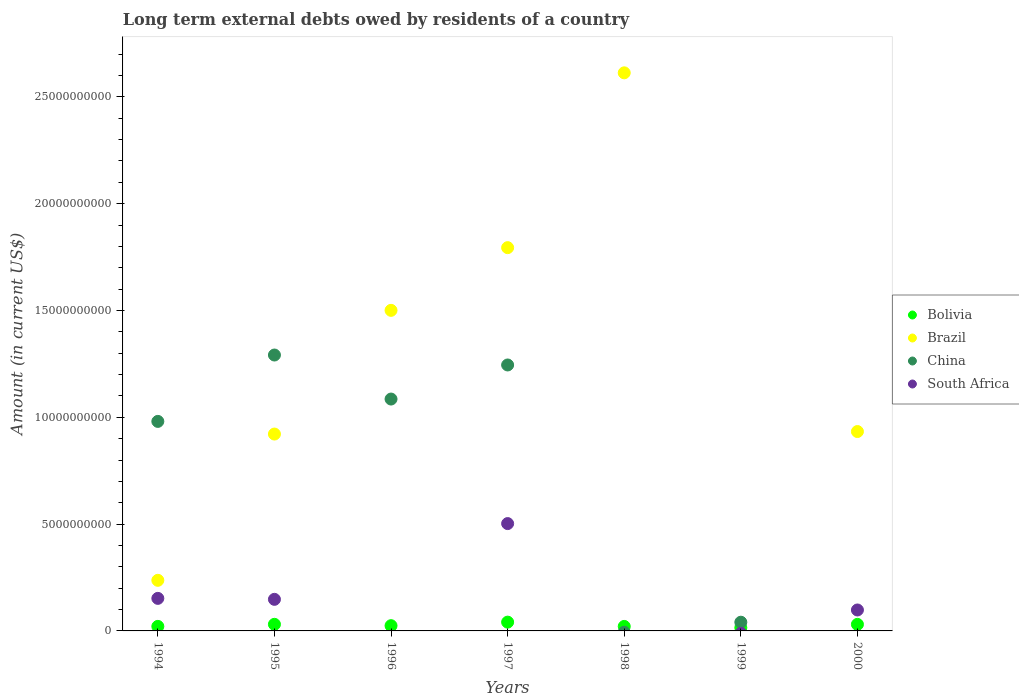How many different coloured dotlines are there?
Keep it short and to the point. 4. What is the amount of long-term external debts owed by residents in Brazil in 1999?
Provide a short and direct response. 0. Across all years, what is the maximum amount of long-term external debts owed by residents in South Africa?
Keep it short and to the point. 5.02e+09. What is the total amount of long-term external debts owed by residents in China in the graph?
Ensure brevity in your answer.  4.64e+1. What is the difference between the amount of long-term external debts owed by residents in South Africa in 1994 and that in 1995?
Offer a terse response. 4.52e+07. What is the difference between the amount of long-term external debts owed by residents in Brazil in 1995 and the amount of long-term external debts owed by residents in South Africa in 1997?
Ensure brevity in your answer.  4.19e+09. What is the average amount of long-term external debts owed by residents in China per year?
Make the answer very short. 6.63e+09. In the year 1997, what is the difference between the amount of long-term external debts owed by residents in Brazil and amount of long-term external debts owed by residents in South Africa?
Offer a terse response. 1.29e+1. In how many years, is the amount of long-term external debts owed by residents in Brazil greater than 8000000000 US$?
Offer a very short reply. 5. What is the ratio of the amount of long-term external debts owed by residents in South Africa in 1994 to that in 1997?
Provide a succinct answer. 0.3. What is the difference between the highest and the second highest amount of long-term external debts owed by residents in Brazil?
Provide a short and direct response. 8.18e+09. What is the difference between the highest and the lowest amount of long-term external debts owed by residents in Bolivia?
Offer a terse response. 2.60e+08. In how many years, is the amount of long-term external debts owed by residents in Brazil greater than the average amount of long-term external debts owed by residents in Brazil taken over all years?
Keep it short and to the point. 3. Is the sum of the amount of long-term external debts owed by residents in Bolivia in 1997 and 1999 greater than the maximum amount of long-term external debts owed by residents in South Africa across all years?
Provide a succinct answer. No. Is it the case that in every year, the sum of the amount of long-term external debts owed by residents in China and amount of long-term external debts owed by residents in South Africa  is greater than the sum of amount of long-term external debts owed by residents in Bolivia and amount of long-term external debts owed by residents in Brazil?
Provide a short and direct response. No. Does the amount of long-term external debts owed by residents in Bolivia monotonically increase over the years?
Your answer should be very brief. No. How many dotlines are there?
Your response must be concise. 4. How many years are there in the graph?
Offer a terse response. 7. What is the difference between two consecutive major ticks on the Y-axis?
Offer a very short reply. 5.00e+09. Are the values on the major ticks of Y-axis written in scientific E-notation?
Ensure brevity in your answer.  No. Does the graph contain any zero values?
Your answer should be very brief. Yes. How are the legend labels stacked?
Provide a short and direct response. Vertical. What is the title of the graph?
Your response must be concise. Long term external debts owed by residents of a country. Does "Iceland" appear as one of the legend labels in the graph?
Give a very brief answer. No. What is the label or title of the X-axis?
Offer a terse response. Years. What is the Amount (in current US$) in Bolivia in 1994?
Your response must be concise. 2.12e+08. What is the Amount (in current US$) of Brazil in 1994?
Ensure brevity in your answer.  2.37e+09. What is the Amount (in current US$) of China in 1994?
Offer a terse response. 9.81e+09. What is the Amount (in current US$) of South Africa in 1994?
Offer a terse response. 1.52e+09. What is the Amount (in current US$) in Bolivia in 1995?
Make the answer very short. 3.09e+08. What is the Amount (in current US$) of Brazil in 1995?
Keep it short and to the point. 9.22e+09. What is the Amount (in current US$) in China in 1995?
Give a very brief answer. 1.29e+1. What is the Amount (in current US$) of South Africa in 1995?
Provide a succinct answer. 1.48e+09. What is the Amount (in current US$) of Bolivia in 1996?
Keep it short and to the point. 2.46e+08. What is the Amount (in current US$) in Brazil in 1996?
Give a very brief answer. 1.50e+1. What is the Amount (in current US$) of China in 1996?
Your answer should be very brief. 1.09e+1. What is the Amount (in current US$) of South Africa in 1996?
Offer a very short reply. 0. What is the Amount (in current US$) of Bolivia in 1997?
Provide a short and direct response. 4.11e+08. What is the Amount (in current US$) of Brazil in 1997?
Ensure brevity in your answer.  1.79e+1. What is the Amount (in current US$) of China in 1997?
Provide a short and direct response. 1.24e+1. What is the Amount (in current US$) of South Africa in 1997?
Offer a very short reply. 5.02e+09. What is the Amount (in current US$) in Bolivia in 1998?
Offer a terse response. 2.10e+08. What is the Amount (in current US$) of Brazil in 1998?
Provide a short and direct response. 2.61e+1. What is the Amount (in current US$) of China in 1998?
Give a very brief answer. 0. What is the Amount (in current US$) in South Africa in 1998?
Your response must be concise. 0. What is the Amount (in current US$) of Bolivia in 1999?
Make the answer very short. 1.51e+08. What is the Amount (in current US$) of China in 1999?
Give a very brief answer. 4.08e+08. What is the Amount (in current US$) of Bolivia in 2000?
Offer a very short reply. 3.07e+08. What is the Amount (in current US$) in Brazil in 2000?
Your answer should be compact. 9.33e+09. What is the Amount (in current US$) of South Africa in 2000?
Keep it short and to the point. 9.80e+08. Across all years, what is the maximum Amount (in current US$) of Bolivia?
Your answer should be very brief. 4.11e+08. Across all years, what is the maximum Amount (in current US$) in Brazil?
Give a very brief answer. 2.61e+1. Across all years, what is the maximum Amount (in current US$) of China?
Offer a terse response. 1.29e+1. Across all years, what is the maximum Amount (in current US$) in South Africa?
Provide a short and direct response. 5.02e+09. Across all years, what is the minimum Amount (in current US$) of Bolivia?
Ensure brevity in your answer.  1.51e+08. Across all years, what is the minimum Amount (in current US$) of South Africa?
Provide a succinct answer. 0. What is the total Amount (in current US$) in Bolivia in the graph?
Offer a very short reply. 1.85e+09. What is the total Amount (in current US$) of Brazil in the graph?
Ensure brevity in your answer.  8.00e+1. What is the total Amount (in current US$) of China in the graph?
Your answer should be compact. 4.64e+1. What is the total Amount (in current US$) in South Africa in the graph?
Your response must be concise. 9.01e+09. What is the difference between the Amount (in current US$) of Bolivia in 1994 and that in 1995?
Your response must be concise. -9.73e+07. What is the difference between the Amount (in current US$) in Brazil in 1994 and that in 1995?
Keep it short and to the point. -6.85e+09. What is the difference between the Amount (in current US$) in China in 1994 and that in 1995?
Keep it short and to the point. -3.11e+09. What is the difference between the Amount (in current US$) in South Africa in 1994 and that in 1995?
Provide a short and direct response. 4.52e+07. What is the difference between the Amount (in current US$) in Bolivia in 1994 and that in 1996?
Give a very brief answer. -3.39e+07. What is the difference between the Amount (in current US$) in Brazil in 1994 and that in 1996?
Keep it short and to the point. -1.26e+1. What is the difference between the Amount (in current US$) in China in 1994 and that in 1996?
Your answer should be very brief. -1.05e+09. What is the difference between the Amount (in current US$) of Bolivia in 1994 and that in 1997?
Your answer should be very brief. -1.99e+08. What is the difference between the Amount (in current US$) of Brazil in 1994 and that in 1997?
Your answer should be compact. -1.56e+1. What is the difference between the Amount (in current US$) of China in 1994 and that in 1997?
Your answer should be compact. -2.64e+09. What is the difference between the Amount (in current US$) in South Africa in 1994 and that in 1997?
Provide a short and direct response. -3.50e+09. What is the difference between the Amount (in current US$) of Bolivia in 1994 and that in 1998?
Keep it short and to the point. 1.55e+06. What is the difference between the Amount (in current US$) in Brazil in 1994 and that in 1998?
Provide a short and direct response. -2.38e+1. What is the difference between the Amount (in current US$) in Bolivia in 1994 and that in 1999?
Your answer should be very brief. 6.07e+07. What is the difference between the Amount (in current US$) of China in 1994 and that in 1999?
Provide a short and direct response. 9.40e+09. What is the difference between the Amount (in current US$) in Bolivia in 1994 and that in 2000?
Your answer should be compact. -9.52e+07. What is the difference between the Amount (in current US$) in Brazil in 1994 and that in 2000?
Ensure brevity in your answer.  -6.96e+09. What is the difference between the Amount (in current US$) of South Africa in 1994 and that in 2000?
Offer a terse response. 5.43e+08. What is the difference between the Amount (in current US$) of Bolivia in 1995 and that in 1996?
Keep it short and to the point. 6.34e+07. What is the difference between the Amount (in current US$) of Brazil in 1995 and that in 1996?
Ensure brevity in your answer.  -5.79e+09. What is the difference between the Amount (in current US$) of China in 1995 and that in 1996?
Provide a short and direct response. 2.06e+09. What is the difference between the Amount (in current US$) of Bolivia in 1995 and that in 1997?
Provide a short and direct response. -1.02e+08. What is the difference between the Amount (in current US$) of Brazil in 1995 and that in 1997?
Give a very brief answer. -8.73e+09. What is the difference between the Amount (in current US$) in China in 1995 and that in 1997?
Provide a succinct answer. 4.66e+08. What is the difference between the Amount (in current US$) of South Africa in 1995 and that in 1997?
Ensure brevity in your answer.  -3.55e+09. What is the difference between the Amount (in current US$) in Bolivia in 1995 and that in 1998?
Give a very brief answer. 9.88e+07. What is the difference between the Amount (in current US$) of Brazil in 1995 and that in 1998?
Your response must be concise. -1.69e+1. What is the difference between the Amount (in current US$) in Bolivia in 1995 and that in 1999?
Your response must be concise. 1.58e+08. What is the difference between the Amount (in current US$) in China in 1995 and that in 1999?
Offer a very short reply. 1.25e+1. What is the difference between the Amount (in current US$) in Bolivia in 1995 and that in 2000?
Provide a succinct answer. 2.06e+06. What is the difference between the Amount (in current US$) in Brazil in 1995 and that in 2000?
Ensure brevity in your answer.  -1.18e+08. What is the difference between the Amount (in current US$) in South Africa in 1995 and that in 2000?
Provide a succinct answer. 4.98e+08. What is the difference between the Amount (in current US$) in Bolivia in 1996 and that in 1997?
Offer a very short reply. -1.65e+08. What is the difference between the Amount (in current US$) in Brazil in 1996 and that in 1997?
Ensure brevity in your answer.  -2.93e+09. What is the difference between the Amount (in current US$) of China in 1996 and that in 1997?
Provide a short and direct response. -1.60e+09. What is the difference between the Amount (in current US$) of Bolivia in 1996 and that in 1998?
Ensure brevity in your answer.  3.54e+07. What is the difference between the Amount (in current US$) in Brazil in 1996 and that in 1998?
Ensure brevity in your answer.  -1.11e+1. What is the difference between the Amount (in current US$) in Bolivia in 1996 and that in 1999?
Your answer should be very brief. 9.46e+07. What is the difference between the Amount (in current US$) of China in 1996 and that in 1999?
Your response must be concise. 1.04e+1. What is the difference between the Amount (in current US$) of Bolivia in 1996 and that in 2000?
Make the answer very short. -6.13e+07. What is the difference between the Amount (in current US$) in Brazil in 1996 and that in 2000?
Ensure brevity in your answer.  5.67e+09. What is the difference between the Amount (in current US$) of Bolivia in 1997 and that in 1998?
Offer a very short reply. 2.01e+08. What is the difference between the Amount (in current US$) in Brazil in 1997 and that in 1998?
Your answer should be compact. -8.18e+09. What is the difference between the Amount (in current US$) in Bolivia in 1997 and that in 1999?
Keep it short and to the point. 2.60e+08. What is the difference between the Amount (in current US$) in China in 1997 and that in 1999?
Your answer should be compact. 1.20e+1. What is the difference between the Amount (in current US$) of Bolivia in 1997 and that in 2000?
Give a very brief answer. 1.04e+08. What is the difference between the Amount (in current US$) of Brazil in 1997 and that in 2000?
Provide a succinct answer. 8.61e+09. What is the difference between the Amount (in current US$) of South Africa in 1997 and that in 2000?
Your answer should be very brief. 4.04e+09. What is the difference between the Amount (in current US$) in Bolivia in 1998 and that in 1999?
Keep it short and to the point. 5.91e+07. What is the difference between the Amount (in current US$) in Bolivia in 1998 and that in 2000?
Keep it short and to the point. -9.68e+07. What is the difference between the Amount (in current US$) in Brazil in 1998 and that in 2000?
Make the answer very short. 1.68e+1. What is the difference between the Amount (in current US$) in Bolivia in 1999 and that in 2000?
Offer a very short reply. -1.56e+08. What is the difference between the Amount (in current US$) in Bolivia in 1994 and the Amount (in current US$) in Brazil in 1995?
Your answer should be very brief. -9.00e+09. What is the difference between the Amount (in current US$) in Bolivia in 1994 and the Amount (in current US$) in China in 1995?
Keep it short and to the point. -1.27e+1. What is the difference between the Amount (in current US$) in Bolivia in 1994 and the Amount (in current US$) in South Africa in 1995?
Make the answer very short. -1.27e+09. What is the difference between the Amount (in current US$) of Brazil in 1994 and the Amount (in current US$) of China in 1995?
Your answer should be very brief. -1.05e+1. What is the difference between the Amount (in current US$) in Brazil in 1994 and the Amount (in current US$) in South Africa in 1995?
Provide a succinct answer. 8.90e+08. What is the difference between the Amount (in current US$) of China in 1994 and the Amount (in current US$) of South Africa in 1995?
Offer a terse response. 8.33e+09. What is the difference between the Amount (in current US$) in Bolivia in 1994 and the Amount (in current US$) in Brazil in 1996?
Your response must be concise. -1.48e+1. What is the difference between the Amount (in current US$) of Bolivia in 1994 and the Amount (in current US$) of China in 1996?
Offer a very short reply. -1.06e+1. What is the difference between the Amount (in current US$) in Brazil in 1994 and the Amount (in current US$) in China in 1996?
Ensure brevity in your answer.  -8.49e+09. What is the difference between the Amount (in current US$) in Bolivia in 1994 and the Amount (in current US$) in Brazil in 1997?
Ensure brevity in your answer.  -1.77e+1. What is the difference between the Amount (in current US$) in Bolivia in 1994 and the Amount (in current US$) in China in 1997?
Provide a succinct answer. -1.22e+1. What is the difference between the Amount (in current US$) in Bolivia in 1994 and the Amount (in current US$) in South Africa in 1997?
Keep it short and to the point. -4.81e+09. What is the difference between the Amount (in current US$) of Brazil in 1994 and the Amount (in current US$) of China in 1997?
Ensure brevity in your answer.  -1.01e+1. What is the difference between the Amount (in current US$) in Brazil in 1994 and the Amount (in current US$) in South Africa in 1997?
Offer a terse response. -2.66e+09. What is the difference between the Amount (in current US$) in China in 1994 and the Amount (in current US$) in South Africa in 1997?
Your answer should be very brief. 4.78e+09. What is the difference between the Amount (in current US$) of Bolivia in 1994 and the Amount (in current US$) of Brazil in 1998?
Your response must be concise. -2.59e+1. What is the difference between the Amount (in current US$) of Bolivia in 1994 and the Amount (in current US$) of China in 1999?
Provide a short and direct response. -1.96e+08. What is the difference between the Amount (in current US$) of Brazil in 1994 and the Amount (in current US$) of China in 1999?
Provide a short and direct response. 1.96e+09. What is the difference between the Amount (in current US$) of Bolivia in 1994 and the Amount (in current US$) of Brazil in 2000?
Give a very brief answer. -9.12e+09. What is the difference between the Amount (in current US$) of Bolivia in 1994 and the Amount (in current US$) of South Africa in 2000?
Offer a terse response. -7.68e+08. What is the difference between the Amount (in current US$) in Brazil in 1994 and the Amount (in current US$) in South Africa in 2000?
Give a very brief answer. 1.39e+09. What is the difference between the Amount (in current US$) in China in 1994 and the Amount (in current US$) in South Africa in 2000?
Provide a succinct answer. 8.83e+09. What is the difference between the Amount (in current US$) in Bolivia in 1995 and the Amount (in current US$) in Brazil in 1996?
Ensure brevity in your answer.  -1.47e+1. What is the difference between the Amount (in current US$) of Bolivia in 1995 and the Amount (in current US$) of China in 1996?
Provide a short and direct response. -1.05e+1. What is the difference between the Amount (in current US$) of Brazil in 1995 and the Amount (in current US$) of China in 1996?
Your answer should be compact. -1.64e+09. What is the difference between the Amount (in current US$) in Bolivia in 1995 and the Amount (in current US$) in Brazil in 1997?
Provide a succinct answer. -1.76e+1. What is the difference between the Amount (in current US$) in Bolivia in 1995 and the Amount (in current US$) in China in 1997?
Your answer should be compact. -1.21e+1. What is the difference between the Amount (in current US$) of Bolivia in 1995 and the Amount (in current US$) of South Africa in 1997?
Provide a short and direct response. -4.72e+09. What is the difference between the Amount (in current US$) of Brazil in 1995 and the Amount (in current US$) of China in 1997?
Offer a very short reply. -3.23e+09. What is the difference between the Amount (in current US$) in Brazil in 1995 and the Amount (in current US$) in South Africa in 1997?
Keep it short and to the point. 4.19e+09. What is the difference between the Amount (in current US$) of China in 1995 and the Amount (in current US$) of South Africa in 1997?
Give a very brief answer. 7.89e+09. What is the difference between the Amount (in current US$) of Bolivia in 1995 and the Amount (in current US$) of Brazil in 1998?
Ensure brevity in your answer.  -2.58e+1. What is the difference between the Amount (in current US$) of Bolivia in 1995 and the Amount (in current US$) of China in 1999?
Your response must be concise. -9.88e+07. What is the difference between the Amount (in current US$) in Brazil in 1995 and the Amount (in current US$) in China in 1999?
Provide a short and direct response. 8.81e+09. What is the difference between the Amount (in current US$) of Bolivia in 1995 and the Amount (in current US$) of Brazil in 2000?
Your answer should be very brief. -9.02e+09. What is the difference between the Amount (in current US$) in Bolivia in 1995 and the Amount (in current US$) in South Africa in 2000?
Provide a short and direct response. -6.71e+08. What is the difference between the Amount (in current US$) in Brazil in 1995 and the Amount (in current US$) in South Africa in 2000?
Provide a succinct answer. 8.23e+09. What is the difference between the Amount (in current US$) of China in 1995 and the Amount (in current US$) of South Africa in 2000?
Your answer should be very brief. 1.19e+1. What is the difference between the Amount (in current US$) of Bolivia in 1996 and the Amount (in current US$) of Brazil in 1997?
Provide a succinct answer. -1.77e+1. What is the difference between the Amount (in current US$) in Bolivia in 1996 and the Amount (in current US$) in China in 1997?
Ensure brevity in your answer.  -1.22e+1. What is the difference between the Amount (in current US$) of Bolivia in 1996 and the Amount (in current US$) of South Africa in 1997?
Give a very brief answer. -4.78e+09. What is the difference between the Amount (in current US$) of Brazil in 1996 and the Amount (in current US$) of China in 1997?
Ensure brevity in your answer.  2.56e+09. What is the difference between the Amount (in current US$) in Brazil in 1996 and the Amount (in current US$) in South Africa in 1997?
Keep it short and to the point. 9.98e+09. What is the difference between the Amount (in current US$) of China in 1996 and the Amount (in current US$) of South Africa in 1997?
Provide a succinct answer. 5.83e+09. What is the difference between the Amount (in current US$) of Bolivia in 1996 and the Amount (in current US$) of Brazil in 1998?
Ensure brevity in your answer.  -2.59e+1. What is the difference between the Amount (in current US$) in Bolivia in 1996 and the Amount (in current US$) in China in 1999?
Offer a terse response. -1.62e+08. What is the difference between the Amount (in current US$) in Brazil in 1996 and the Amount (in current US$) in China in 1999?
Provide a short and direct response. 1.46e+1. What is the difference between the Amount (in current US$) in Bolivia in 1996 and the Amount (in current US$) in Brazil in 2000?
Provide a succinct answer. -9.09e+09. What is the difference between the Amount (in current US$) in Bolivia in 1996 and the Amount (in current US$) in South Africa in 2000?
Offer a very short reply. -7.35e+08. What is the difference between the Amount (in current US$) in Brazil in 1996 and the Amount (in current US$) in South Africa in 2000?
Your response must be concise. 1.40e+1. What is the difference between the Amount (in current US$) in China in 1996 and the Amount (in current US$) in South Africa in 2000?
Provide a succinct answer. 9.87e+09. What is the difference between the Amount (in current US$) of Bolivia in 1997 and the Amount (in current US$) of Brazil in 1998?
Your answer should be very brief. -2.57e+1. What is the difference between the Amount (in current US$) of Bolivia in 1997 and the Amount (in current US$) of China in 1999?
Offer a very short reply. 3.34e+06. What is the difference between the Amount (in current US$) of Brazil in 1997 and the Amount (in current US$) of China in 1999?
Offer a terse response. 1.75e+1. What is the difference between the Amount (in current US$) of Bolivia in 1997 and the Amount (in current US$) of Brazil in 2000?
Keep it short and to the point. -8.92e+09. What is the difference between the Amount (in current US$) in Bolivia in 1997 and the Amount (in current US$) in South Africa in 2000?
Ensure brevity in your answer.  -5.69e+08. What is the difference between the Amount (in current US$) in Brazil in 1997 and the Amount (in current US$) in South Africa in 2000?
Offer a terse response. 1.70e+1. What is the difference between the Amount (in current US$) of China in 1997 and the Amount (in current US$) of South Africa in 2000?
Provide a succinct answer. 1.15e+1. What is the difference between the Amount (in current US$) of Bolivia in 1998 and the Amount (in current US$) of China in 1999?
Provide a short and direct response. -1.98e+08. What is the difference between the Amount (in current US$) of Brazil in 1998 and the Amount (in current US$) of China in 1999?
Provide a succinct answer. 2.57e+1. What is the difference between the Amount (in current US$) of Bolivia in 1998 and the Amount (in current US$) of Brazil in 2000?
Your response must be concise. -9.12e+09. What is the difference between the Amount (in current US$) in Bolivia in 1998 and the Amount (in current US$) in South Africa in 2000?
Offer a very short reply. -7.70e+08. What is the difference between the Amount (in current US$) in Brazil in 1998 and the Amount (in current US$) in South Africa in 2000?
Your answer should be very brief. 2.51e+1. What is the difference between the Amount (in current US$) of Bolivia in 1999 and the Amount (in current US$) of Brazil in 2000?
Give a very brief answer. -9.18e+09. What is the difference between the Amount (in current US$) in Bolivia in 1999 and the Amount (in current US$) in South Africa in 2000?
Provide a short and direct response. -8.29e+08. What is the difference between the Amount (in current US$) in China in 1999 and the Amount (in current US$) in South Africa in 2000?
Provide a succinct answer. -5.72e+08. What is the average Amount (in current US$) in Bolivia per year?
Keep it short and to the point. 2.64e+08. What is the average Amount (in current US$) of Brazil per year?
Provide a succinct answer. 1.14e+1. What is the average Amount (in current US$) of China per year?
Offer a very short reply. 6.63e+09. What is the average Amount (in current US$) of South Africa per year?
Ensure brevity in your answer.  1.29e+09. In the year 1994, what is the difference between the Amount (in current US$) in Bolivia and Amount (in current US$) in Brazil?
Provide a short and direct response. -2.16e+09. In the year 1994, what is the difference between the Amount (in current US$) in Bolivia and Amount (in current US$) in China?
Give a very brief answer. -9.60e+09. In the year 1994, what is the difference between the Amount (in current US$) of Bolivia and Amount (in current US$) of South Africa?
Your answer should be very brief. -1.31e+09. In the year 1994, what is the difference between the Amount (in current US$) in Brazil and Amount (in current US$) in China?
Your response must be concise. -7.44e+09. In the year 1994, what is the difference between the Amount (in current US$) of Brazil and Amount (in current US$) of South Africa?
Make the answer very short. 8.45e+08. In the year 1994, what is the difference between the Amount (in current US$) in China and Amount (in current US$) in South Africa?
Provide a succinct answer. 8.28e+09. In the year 1995, what is the difference between the Amount (in current US$) in Bolivia and Amount (in current US$) in Brazil?
Give a very brief answer. -8.91e+09. In the year 1995, what is the difference between the Amount (in current US$) in Bolivia and Amount (in current US$) in China?
Keep it short and to the point. -1.26e+1. In the year 1995, what is the difference between the Amount (in current US$) of Bolivia and Amount (in current US$) of South Africa?
Make the answer very short. -1.17e+09. In the year 1995, what is the difference between the Amount (in current US$) in Brazil and Amount (in current US$) in China?
Your response must be concise. -3.70e+09. In the year 1995, what is the difference between the Amount (in current US$) of Brazil and Amount (in current US$) of South Africa?
Ensure brevity in your answer.  7.74e+09. In the year 1995, what is the difference between the Amount (in current US$) in China and Amount (in current US$) in South Africa?
Provide a short and direct response. 1.14e+1. In the year 1996, what is the difference between the Amount (in current US$) of Bolivia and Amount (in current US$) of Brazil?
Provide a succinct answer. -1.48e+1. In the year 1996, what is the difference between the Amount (in current US$) in Bolivia and Amount (in current US$) in China?
Provide a succinct answer. -1.06e+1. In the year 1996, what is the difference between the Amount (in current US$) in Brazil and Amount (in current US$) in China?
Provide a short and direct response. 4.15e+09. In the year 1997, what is the difference between the Amount (in current US$) of Bolivia and Amount (in current US$) of Brazil?
Your response must be concise. -1.75e+1. In the year 1997, what is the difference between the Amount (in current US$) of Bolivia and Amount (in current US$) of China?
Ensure brevity in your answer.  -1.20e+1. In the year 1997, what is the difference between the Amount (in current US$) of Bolivia and Amount (in current US$) of South Africa?
Give a very brief answer. -4.61e+09. In the year 1997, what is the difference between the Amount (in current US$) in Brazil and Amount (in current US$) in China?
Provide a short and direct response. 5.49e+09. In the year 1997, what is the difference between the Amount (in current US$) of Brazil and Amount (in current US$) of South Africa?
Give a very brief answer. 1.29e+1. In the year 1997, what is the difference between the Amount (in current US$) in China and Amount (in current US$) in South Africa?
Offer a very short reply. 7.42e+09. In the year 1998, what is the difference between the Amount (in current US$) in Bolivia and Amount (in current US$) in Brazil?
Offer a very short reply. -2.59e+1. In the year 1999, what is the difference between the Amount (in current US$) of Bolivia and Amount (in current US$) of China?
Offer a terse response. -2.57e+08. In the year 2000, what is the difference between the Amount (in current US$) in Bolivia and Amount (in current US$) in Brazil?
Provide a succinct answer. -9.03e+09. In the year 2000, what is the difference between the Amount (in current US$) in Bolivia and Amount (in current US$) in South Africa?
Provide a short and direct response. -6.73e+08. In the year 2000, what is the difference between the Amount (in current US$) in Brazil and Amount (in current US$) in South Africa?
Provide a short and direct response. 8.35e+09. What is the ratio of the Amount (in current US$) of Bolivia in 1994 to that in 1995?
Ensure brevity in your answer.  0.69. What is the ratio of the Amount (in current US$) in Brazil in 1994 to that in 1995?
Keep it short and to the point. 0.26. What is the ratio of the Amount (in current US$) in China in 1994 to that in 1995?
Your response must be concise. 0.76. What is the ratio of the Amount (in current US$) in South Africa in 1994 to that in 1995?
Your answer should be compact. 1.03. What is the ratio of the Amount (in current US$) of Bolivia in 1994 to that in 1996?
Offer a very short reply. 0.86. What is the ratio of the Amount (in current US$) of Brazil in 1994 to that in 1996?
Offer a terse response. 0.16. What is the ratio of the Amount (in current US$) of China in 1994 to that in 1996?
Your answer should be compact. 0.9. What is the ratio of the Amount (in current US$) of Bolivia in 1994 to that in 1997?
Your response must be concise. 0.52. What is the ratio of the Amount (in current US$) of Brazil in 1994 to that in 1997?
Provide a short and direct response. 0.13. What is the ratio of the Amount (in current US$) in China in 1994 to that in 1997?
Offer a terse response. 0.79. What is the ratio of the Amount (in current US$) of South Africa in 1994 to that in 1997?
Provide a short and direct response. 0.3. What is the ratio of the Amount (in current US$) in Bolivia in 1994 to that in 1998?
Provide a short and direct response. 1.01. What is the ratio of the Amount (in current US$) of Brazil in 1994 to that in 1998?
Offer a terse response. 0.09. What is the ratio of the Amount (in current US$) of Bolivia in 1994 to that in 1999?
Your response must be concise. 1.4. What is the ratio of the Amount (in current US$) of China in 1994 to that in 1999?
Offer a very short reply. 24.04. What is the ratio of the Amount (in current US$) of Bolivia in 1994 to that in 2000?
Provide a succinct answer. 0.69. What is the ratio of the Amount (in current US$) of Brazil in 1994 to that in 2000?
Offer a very short reply. 0.25. What is the ratio of the Amount (in current US$) of South Africa in 1994 to that in 2000?
Provide a succinct answer. 1.55. What is the ratio of the Amount (in current US$) in Bolivia in 1995 to that in 1996?
Keep it short and to the point. 1.26. What is the ratio of the Amount (in current US$) in Brazil in 1995 to that in 1996?
Offer a very short reply. 0.61. What is the ratio of the Amount (in current US$) in China in 1995 to that in 1996?
Provide a succinct answer. 1.19. What is the ratio of the Amount (in current US$) of Bolivia in 1995 to that in 1997?
Your response must be concise. 0.75. What is the ratio of the Amount (in current US$) in Brazil in 1995 to that in 1997?
Your answer should be compact. 0.51. What is the ratio of the Amount (in current US$) of China in 1995 to that in 1997?
Your answer should be compact. 1.04. What is the ratio of the Amount (in current US$) in South Africa in 1995 to that in 1997?
Offer a very short reply. 0.29. What is the ratio of the Amount (in current US$) in Bolivia in 1995 to that in 1998?
Offer a very short reply. 1.47. What is the ratio of the Amount (in current US$) of Brazil in 1995 to that in 1998?
Ensure brevity in your answer.  0.35. What is the ratio of the Amount (in current US$) of Bolivia in 1995 to that in 1999?
Give a very brief answer. 2.04. What is the ratio of the Amount (in current US$) of China in 1995 to that in 1999?
Keep it short and to the point. 31.66. What is the ratio of the Amount (in current US$) in Brazil in 1995 to that in 2000?
Offer a terse response. 0.99. What is the ratio of the Amount (in current US$) of South Africa in 1995 to that in 2000?
Keep it short and to the point. 1.51. What is the ratio of the Amount (in current US$) of Bolivia in 1996 to that in 1997?
Make the answer very short. 0.6. What is the ratio of the Amount (in current US$) in Brazil in 1996 to that in 1997?
Provide a short and direct response. 0.84. What is the ratio of the Amount (in current US$) of China in 1996 to that in 1997?
Your response must be concise. 0.87. What is the ratio of the Amount (in current US$) in Bolivia in 1996 to that in 1998?
Your answer should be compact. 1.17. What is the ratio of the Amount (in current US$) of Brazil in 1996 to that in 1998?
Give a very brief answer. 0.57. What is the ratio of the Amount (in current US$) of Bolivia in 1996 to that in 1999?
Keep it short and to the point. 1.63. What is the ratio of the Amount (in current US$) of China in 1996 to that in 1999?
Give a very brief answer. 26.61. What is the ratio of the Amount (in current US$) in Bolivia in 1996 to that in 2000?
Offer a very short reply. 0.8. What is the ratio of the Amount (in current US$) of Brazil in 1996 to that in 2000?
Provide a short and direct response. 1.61. What is the ratio of the Amount (in current US$) in Bolivia in 1997 to that in 1998?
Make the answer very short. 1.96. What is the ratio of the Amount (in current US$) of Brazil in 1997 to that in 1998?
Your answer should be very brief. 0.69. What is the ratio of the Amount (in current US$) in Bolivia in 1997 to that in 1999?
Give a very brief answer. 2.72. What is the ratio of the Amount (in current US$) of China in 1997 to that in 1999?
Offer a very short reply. 30.52. What is the ratio of the Amount (in current US$) in Bolivia in 1997 to that in 2000?
Provide a succinct answer. 1.34. What is the ratio of the Amount (in current US$) of Brazil in 1997 to that in 2000?
Provide a short and direct response. 1.92. What is the ratio of the Amount (in current US$) in South Africa in 1997 to that in 2000?
Your answer should be very brief. 5.13. What is the ratio of the Amount (in current US$) in Bolivia in 1998 to that in 1999?
Offer a terse response. 1.39. What is the ratio of the Amount (in current US$) in Bolivia in 1998 to that in 2000?
Ensure brevity in your answer.  0.69. What is the ratio of the Amount (in current US$) in Brazil in 1998 to that in 2000?
Make the answer very short. 2.8. What is the ratio of the Amount (in current US$) of Bolivia in 1999 to that in 2000?
Offer a very short reply. 0.49. What is the difference between the highest and the second highest Amount (in current US$) in Bolivia?
Offer a very short reply. 1.02e+08. What is the difference between the highest and the second highest Amount (in current US$) of Brazil?
Keep it short and to the point. 8.18e+09. What is the difference between the highest and the second highest Amount (in current US$) of China?
Your response must be concise. 4.66e+08. What is the difference between the highest and the second highest Amount (in current US$) of South Africa?
Make the answer very short. 3.50e+09. What is the difference between the highest and the lowest Amount (in current US$) in Bolivia?
Your response must be concise. 2.60e+08. What is the difference between the highest and the lowest Amount (in current US$) in Brazil?
Provide a short and direct response. 2.61e+1. What is the difference between the highest and the lowest Amount (in current US$) of China?
Give a very brief answer. 1.29e+1. What is the difference between the highest and the lowest Amount (in current US$) of South Africa?
Your answer should be compact. 5.02e+09. 